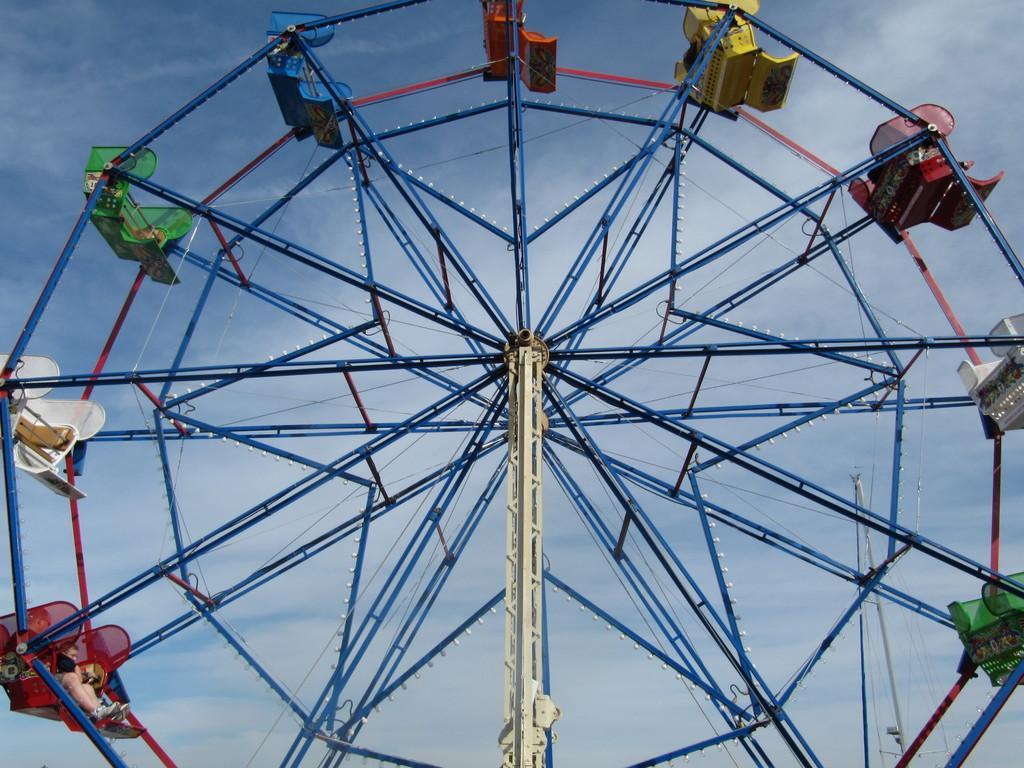How would you summarize this image in a sentence or two? In this image I can see a giant wheel. In the background, I can see the sky. 